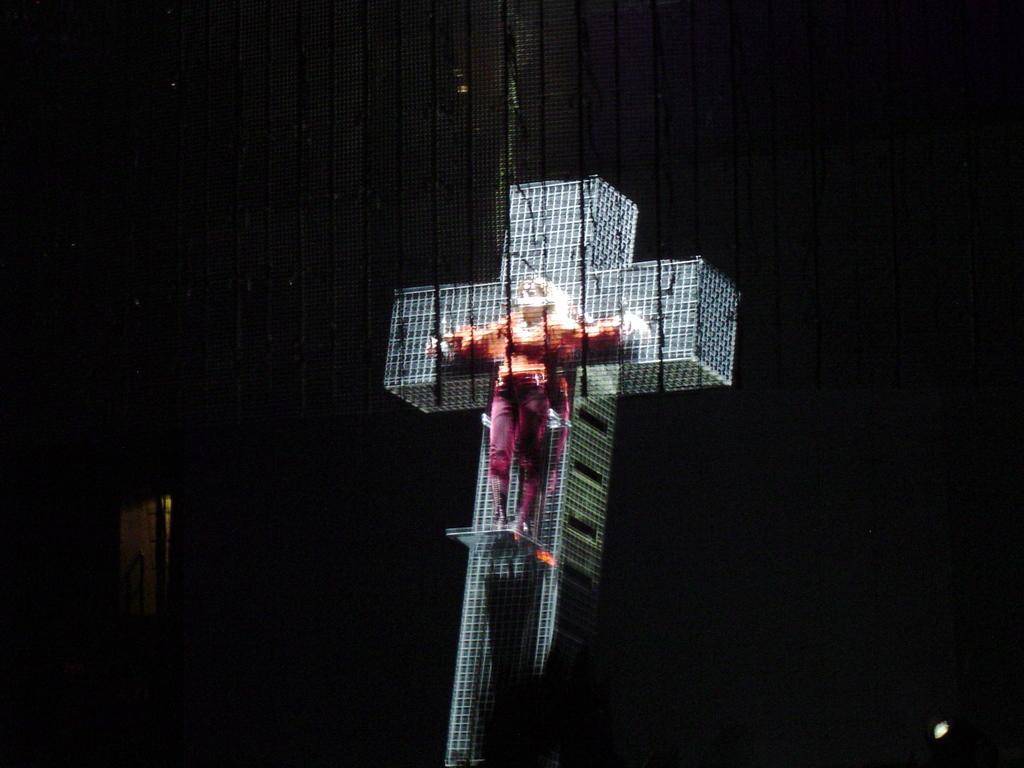Can you describe this image briefly? In this image there is a person standing on the building which is in cross symbol. On the left side of the image there is a door.  